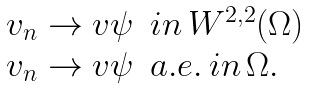<formula> <loc_0><loc_0><loc_500><loc_500>\begin{array} { l l } v _ { n } \rightarrow v \psi & i n \, W ^ { 2 , 2 } ( \Omega ) \\ v _ { n } \rightarrow v \psi & a . e . \, i n \, \Omega . \end{array}</formula> 